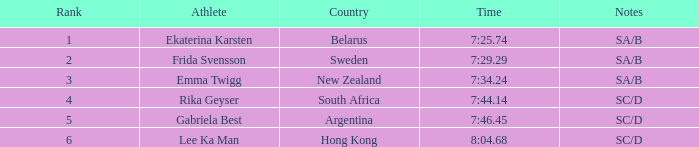What is the time of frida svensson's race that had sa/b under the notes? 7:29.29. 